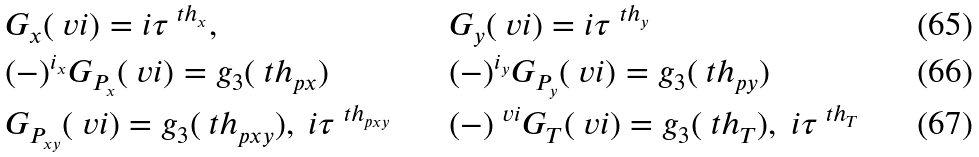<formula> <loc_0><loc_0><loc_500><loc_500>& G _ { x } ( \ v i ) = i \tau ^ { \ t h _ { x } } , & & G _ { y } ( \ v i ) = i \tau ^ { \ t h _ { y } } \\ & ( - ) ^ { i _ { x } } G _ { P _ { x } } ( \ v i ) = g _ { 3 } ( \ t h _ { p x } ) & & ( - ) ^ { i _ { y } } G _ { P _ { y } } ( \ v i ) = g _ { 3 } ( \ t h _ { p y } ) \\ & G _ { P _ { x y } } ( \ v i ) = g _ { 3 } ( \ t h _ { p x y } ) , \ i \tau ^ { \ t h _ { p x y } } & & ( - ) ^ { \ v i } G _ { T } ( \ v i ) = g _ { 3 } ( \ t h _ { T } ) , \ i \tau ^ { \ t h _ { T } }</formula> 